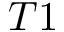Convert formula to latex. <formula><loc_0><loc_0><loc_500><loc_500>T 1</formula> 